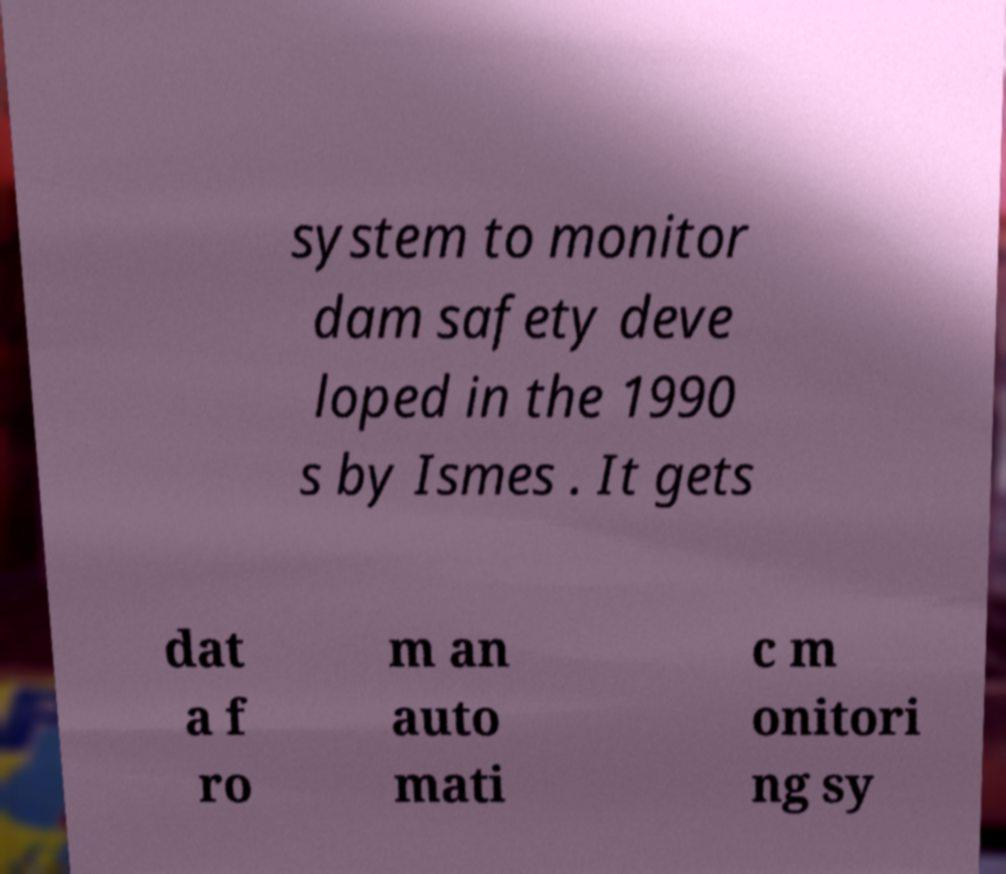For documentation purposes, I need the text within this image transcribed. Could you provide that? system to monitor dam safety deve loped in the 1990 s by Ismes . It gets dat a f ro m an auto mati c m onitori ng sy 